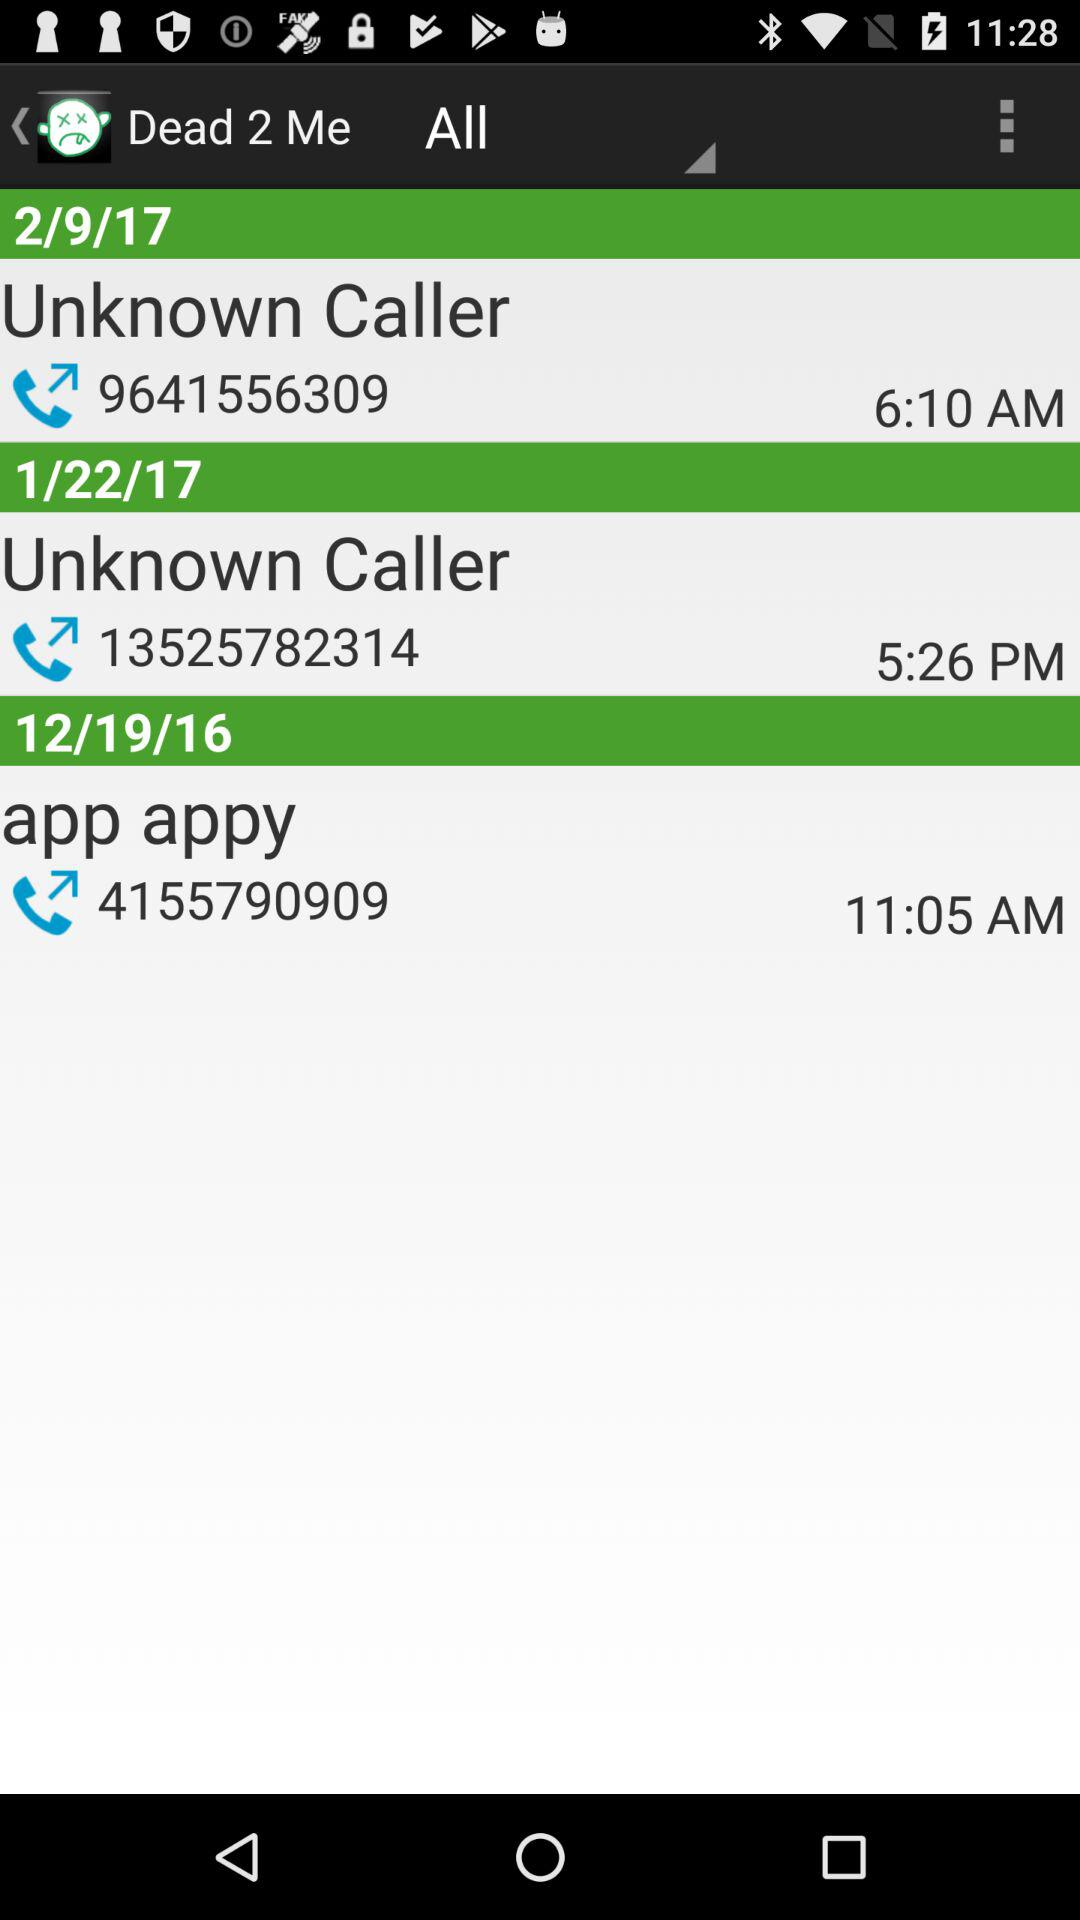What is the name of the application? The name of the application is "Dead 2 Me". 